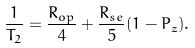Convert formula to latex. <formula><loc_0><loc_0><loc_500><loc_500>\frac { 1 } { T _ { 2 } } = \frac { R _ { o p } } { 4 } + \frac { R _ { s e } } { 5 } ( 1 - P _ { z } ) .</formula> 